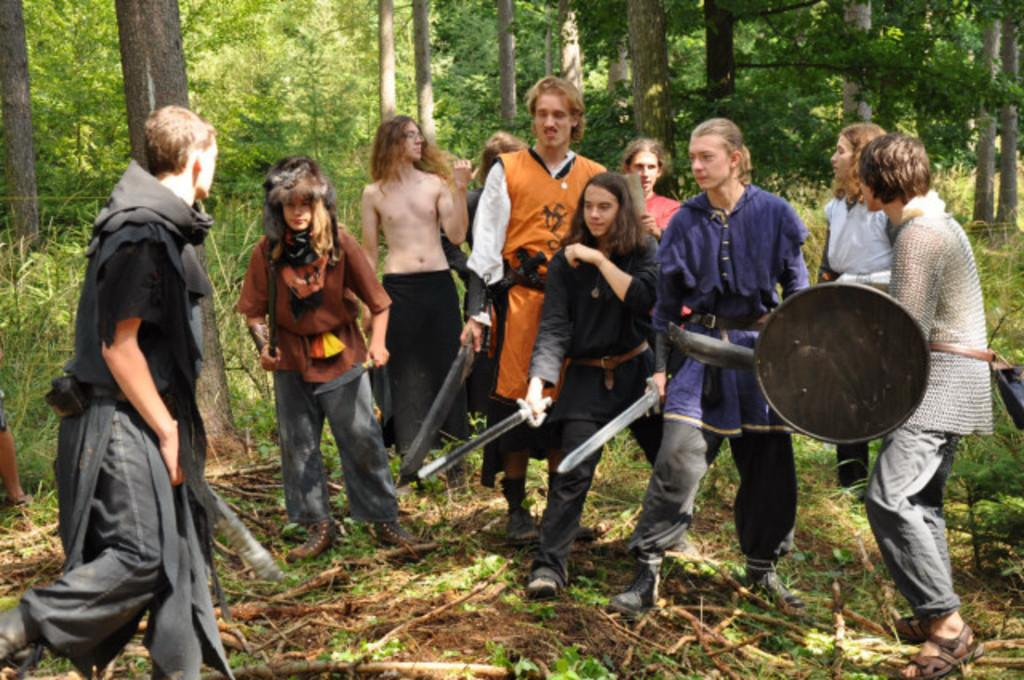What are the people in the center of the image doing? The people are standing in the center of the image and holding swords. What else are the people holding in the image? The people are also holding life-saving objects. What can be seen in the background of the image? There are trees, plants, and grass in the background of the image. What type of lip balm can be seen in the image? There is no lip balm present in the image. How many parcels are being carried by the people in the image? There is no mention of parcels in the image; the people are holding swords and life-saving objects. 